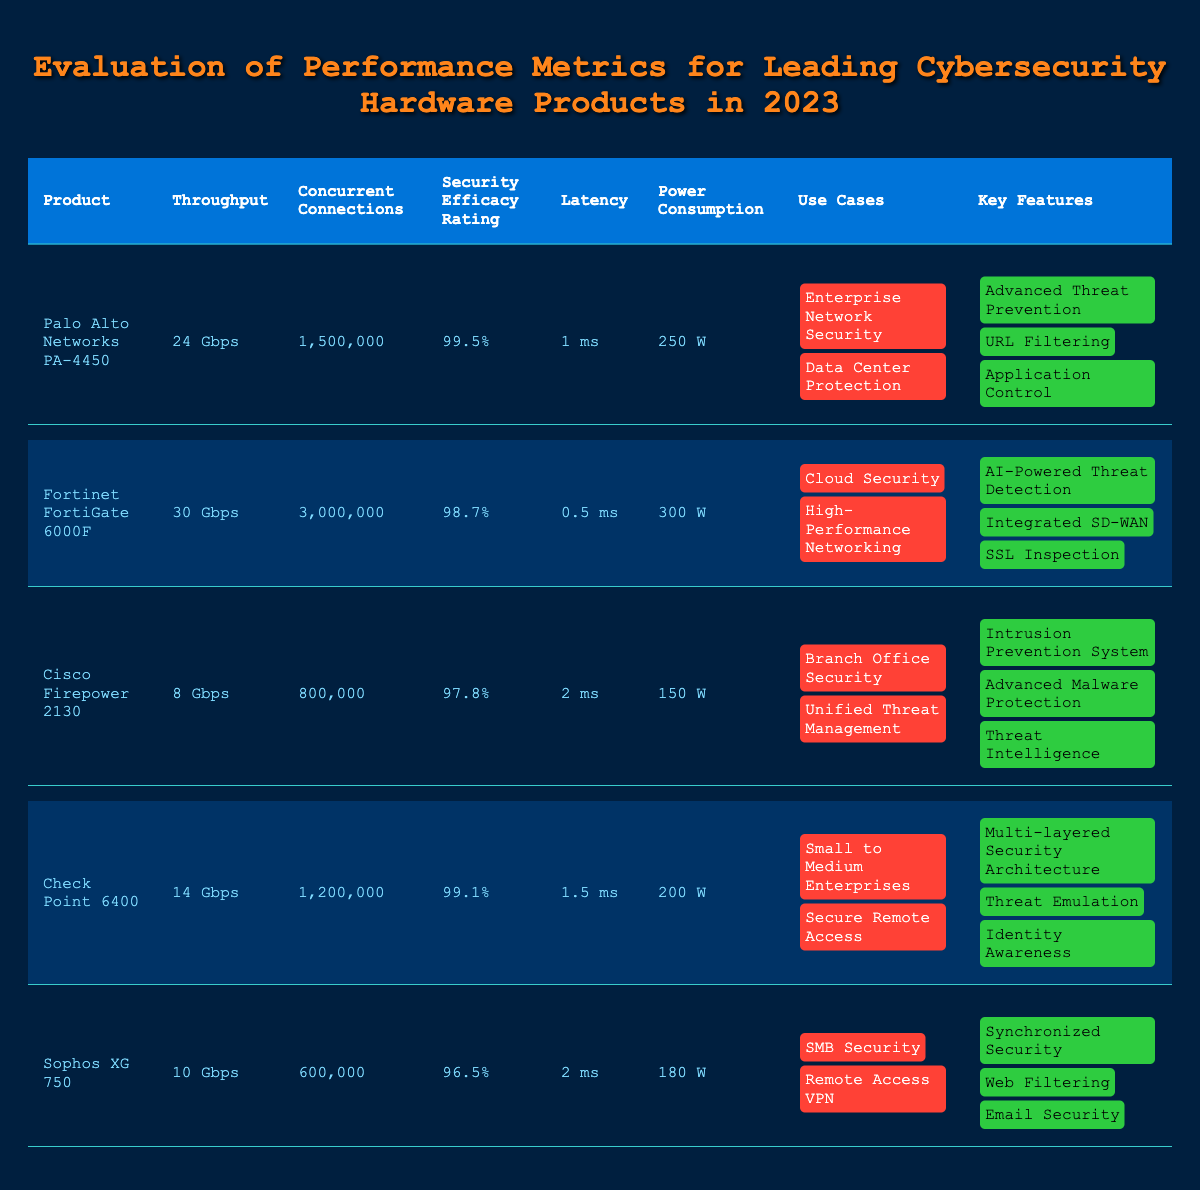What is the throughput of the Fortinet FortiGate 6000F? The table indicates that the Fortinet FortiGate 6000F has a throughput of 30 Gbps.
Answer: 30 Gbps Which product has the lowest power consumption? By comparing the power consumption values, the Cisco Firepower 2130 has the lowest consumption at 150 W.
Answer: Cisco Firepower 2130 Is the security efficacy rating of the Palo Alto Networks PA-4450 higher than 99%? The security efficacy rating for the Palo Alto Networks PA-4450 is 99.5%, which is indeed higher than 99%.
Answer: Yes How many concurrent connections can the Check Point 6400 handle? The table states that the Check Point 6400 can handle 1,200,000 concurrent connections.
Answer: 1,200,000 If you compare the throughput of Cisco Firepower 2130 and Sophos XG 750, which one has better performance? The throughput of Cisco Firepower 2130 is 8 Gbps and for Sophos XG 750 it is 10 Gbps. Since 10 Gbps is greater than 8 Gbps, Sophos XG 750 has better performance.
Answer: Sophos XG 750 What is the average concurrent connections across all products? To find the average, sum the concurrent connections (1,500,000 + 3,000,000 + 800,000 + 1,200,000 + 600,000) = 7,100,000, then divide by 5 (the number of products), which gives 7,100,000/5 = 1,420,000.
Answer: 1,420,000 Is the latency of the Fortinet FortiGate 6000F lesser than that of Check Point 6400? The latency for Fortinet FortiGate 6000F is 0.5 ms, while for Check Point 6400 it is 1.5 ms. Since 0.5 ms is less than 1.5 ms, the statement is true.
Answer: Yes Which product offers AI-powered threat detection? The table shows that the Fortinet FortiGate 6000F includes AI-Powered Threat Detection as a key feature.
Answer: Fortinet FortiGate 6000F What is the difference in throughput between the Palo Alto Networks PA-4450 and the Cisco Firepower 2130? The throughput of Palo Alto Networks PA-4450 is 24 Gbps, and for Cisco Firepower 2130, it is 8 Gbps. The difference is 24 Gbps - 8 Gbps = 16 Gbps.
Answer: 16 Gbps Among the listed products, which one provides the highest security efficacy rating? By comparing the security efficacy ratings, Palo Alto Networks PA-4450 has the highest at 99.5%.
Answer: Palo Alto Networks PA-4450 